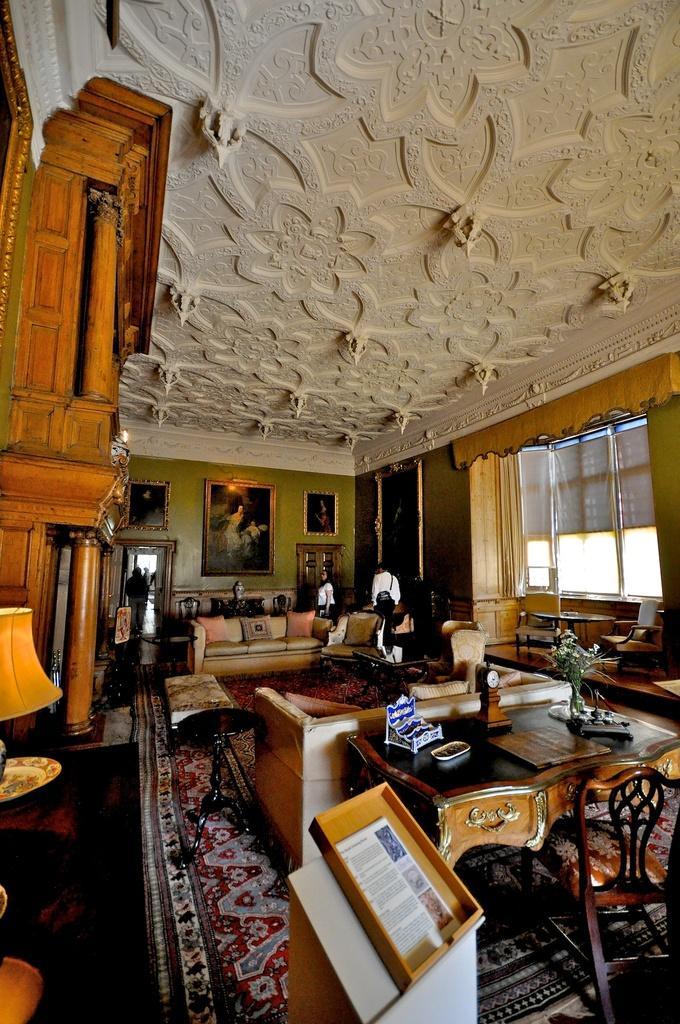Could you give a brief overview of what you see in this image? This is the picture of the room where we have a sofa and some chairs and tables and there is a lamp to the left side and the wooden interior decoration thing and to the roof we have white color design and to the wall we have some frames and some people in the room. 